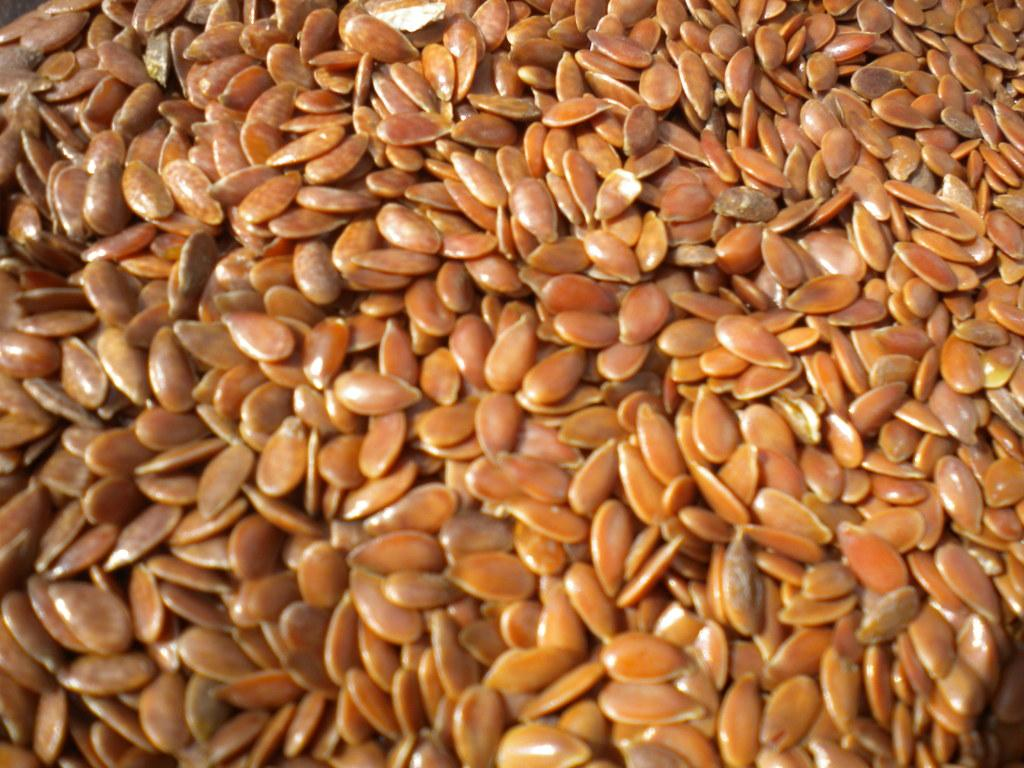What type of small objects can be seen in the image? There are seeds in the image. Can you describe the appearance of the seeds? The seeds may vary in size, shape, and color, but they are generally small and have a distinct texture. What might be the purpose of these seeds? The seeds may be intended for planting, consumption, or decoration, depending on their type and context. How does the zephyr interact with the seeds in the image? There is no zephyr present in the image, so it cannot interact with the seeds. 